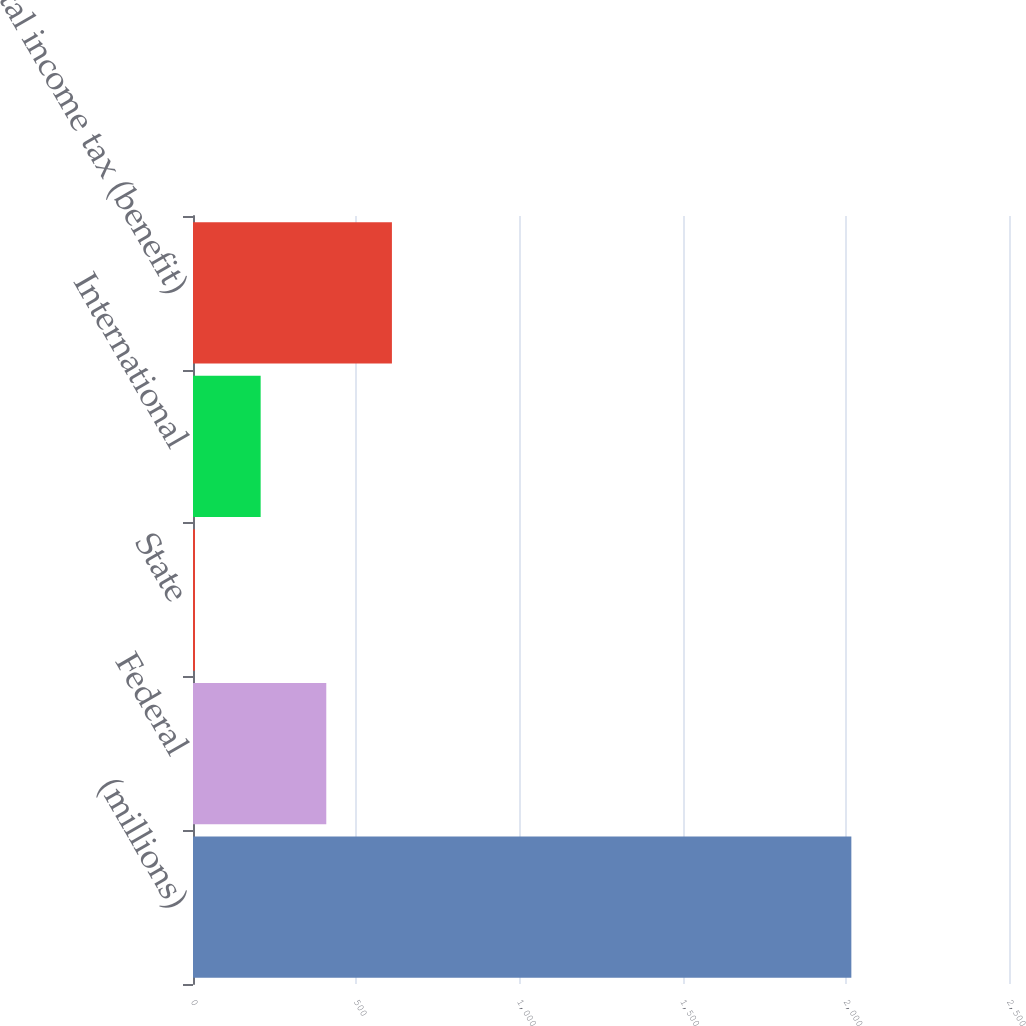<chart> <loc_0><loc_0><loc_500><loc_500><bar_chart><fcel>(millions)<fcel>Federal<fcel>State<fcel>International<fcel>Total income tax (benefit)<nl><fcel>2017<fcel>408.36<fcel>6.2<fcel>207.28<fcel>609.44<nl></chart> 